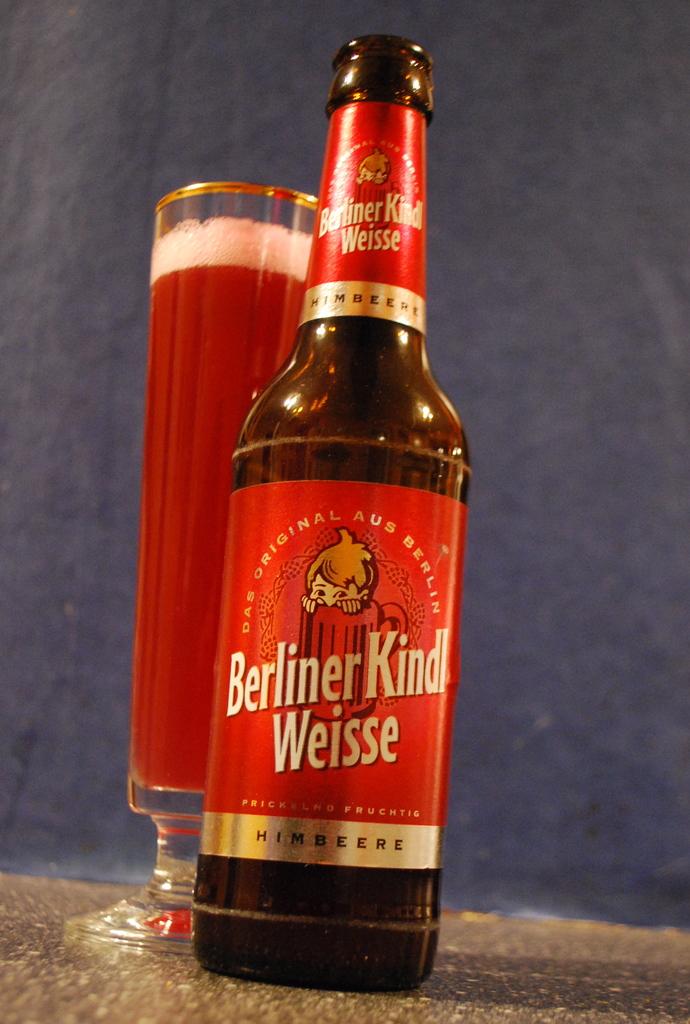What kind of beer is this?
Provide a short and direct response. Berliner kind weisse. What is the word written in black on the silver lining?
Make the answer very short. Himbeere. 